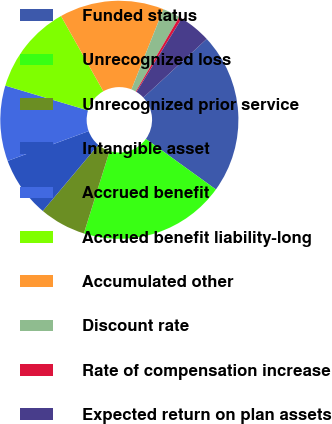Convert chart. <chart><loc_0><loc_0><loc_500><loc_500><pie_chart><fcel>Funded status<fcel>Unrecognized loss<fcel>Unrecognized prior service<fcel>Intangible asset<fcel>Accrued benefit<fcel>Accrued benefit liability-long<fcel>Accumulated other<fcel>Discount rate<fcel>Rate of compensation increase<fcel>Expected return on plan assets<nl><fcel>21.83%<fcel>19.86%<fcel>6.3%<fcel>8.27%<fcel>10.24%<fcel>12.21%<fcel>14.18%<fcel>2.36%<fcel>0.39%<fcel>4.33%<nl></chart> 